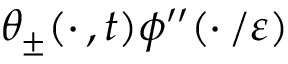<formula> <loc_0><loc_0><loc_500><loc_500>\theta _ { \pm } ( \cdot \, , t ) \phi ^ { \prime \prime } ( \cdot \, / \varepsilon )</formula> 